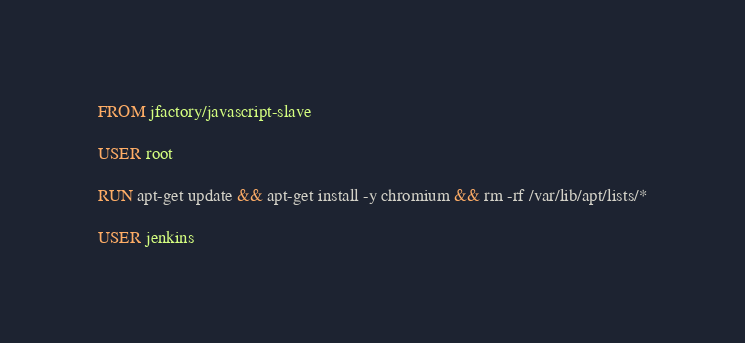<code> <loc_0><loc_0><loc_500><loc_500><_Dockerfile_>FROM jfactory/javascript-slave

USER root

RUN apt-get update && apt-get install -y chromium && rm -rf /var/lib/apt/lists/*

USER jenkins
</code> 